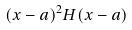<formula> <loc_0><loc_0><loc_500><loc_500>( x - a ) ^ { 2 } H ( x - a )</formula> 